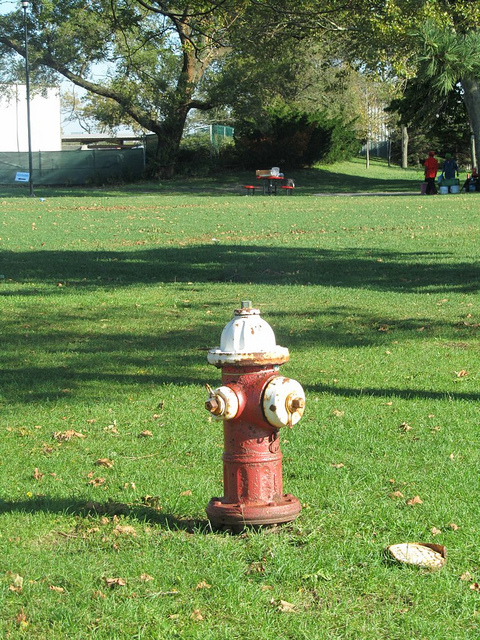<image>What is the sex of the person behind the fire hydrant? The sex of the person behind the fire hydrant is unclear. However, it can be male. What is the sex of the person behind the fire hydrant? I don't know the sex of the person behind the fire hydrant. It seems to be male, but I am not certain. 